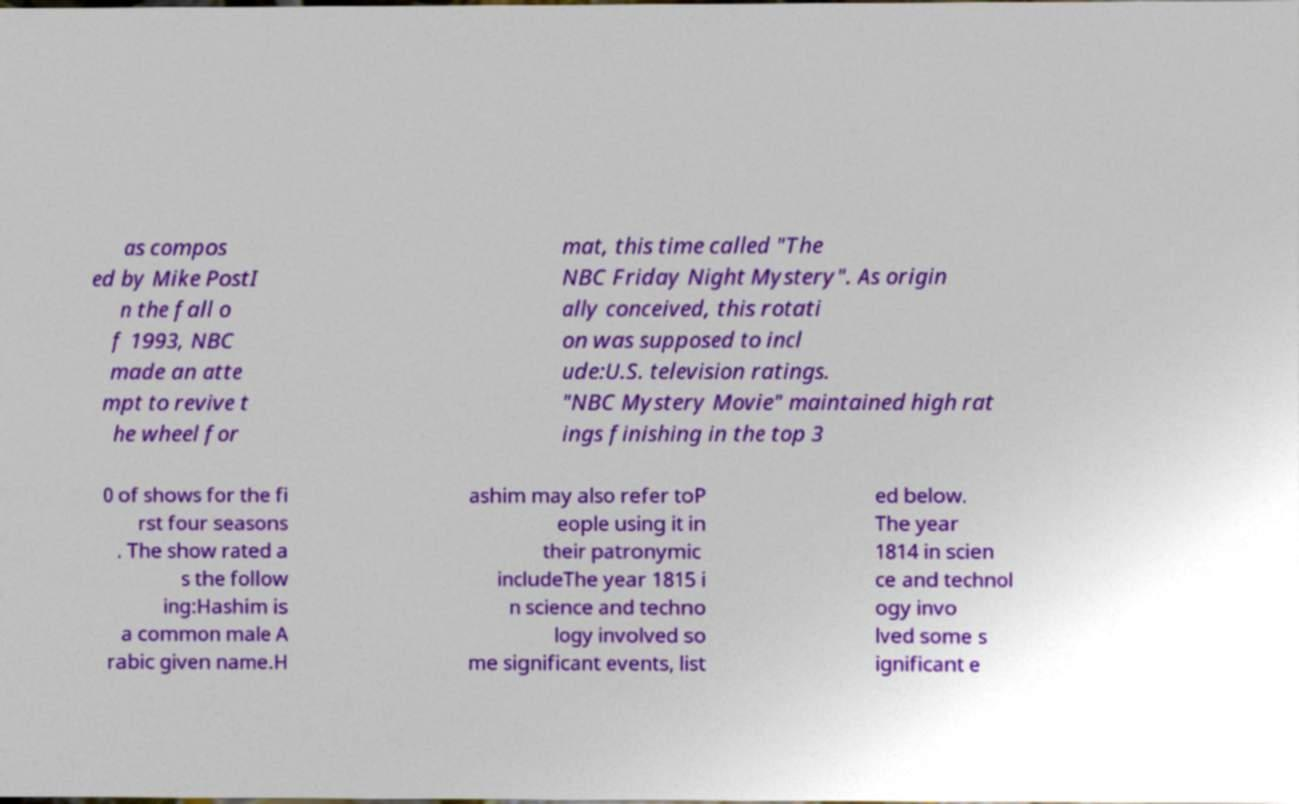There's text embedded in this image that I need extracted. Can you transcribe it verbatim? as compos ed by Mike PostI n the fall o f 1993, NBC made an atte mpt to revive t he wheel for mat, this time called "The NBC Friday Night Mystery". As origin ally conceived, this rotati on was supposed to incl ude:U.S. television ratings. "NBC Mystery Movie" maintained high rat ings finishing in the top 3 0 of shows for the fi rst four seasons . The show rated a s the follow ing:Hashim is a common male A rabic given name.H ashim may also refer toP eople using it in their patronymic includeThe year 1815 i n science and techno logy involved so me significant events, list ed below. The year 1814 in scien ce and technol ogy invo lved some s ignificant e 